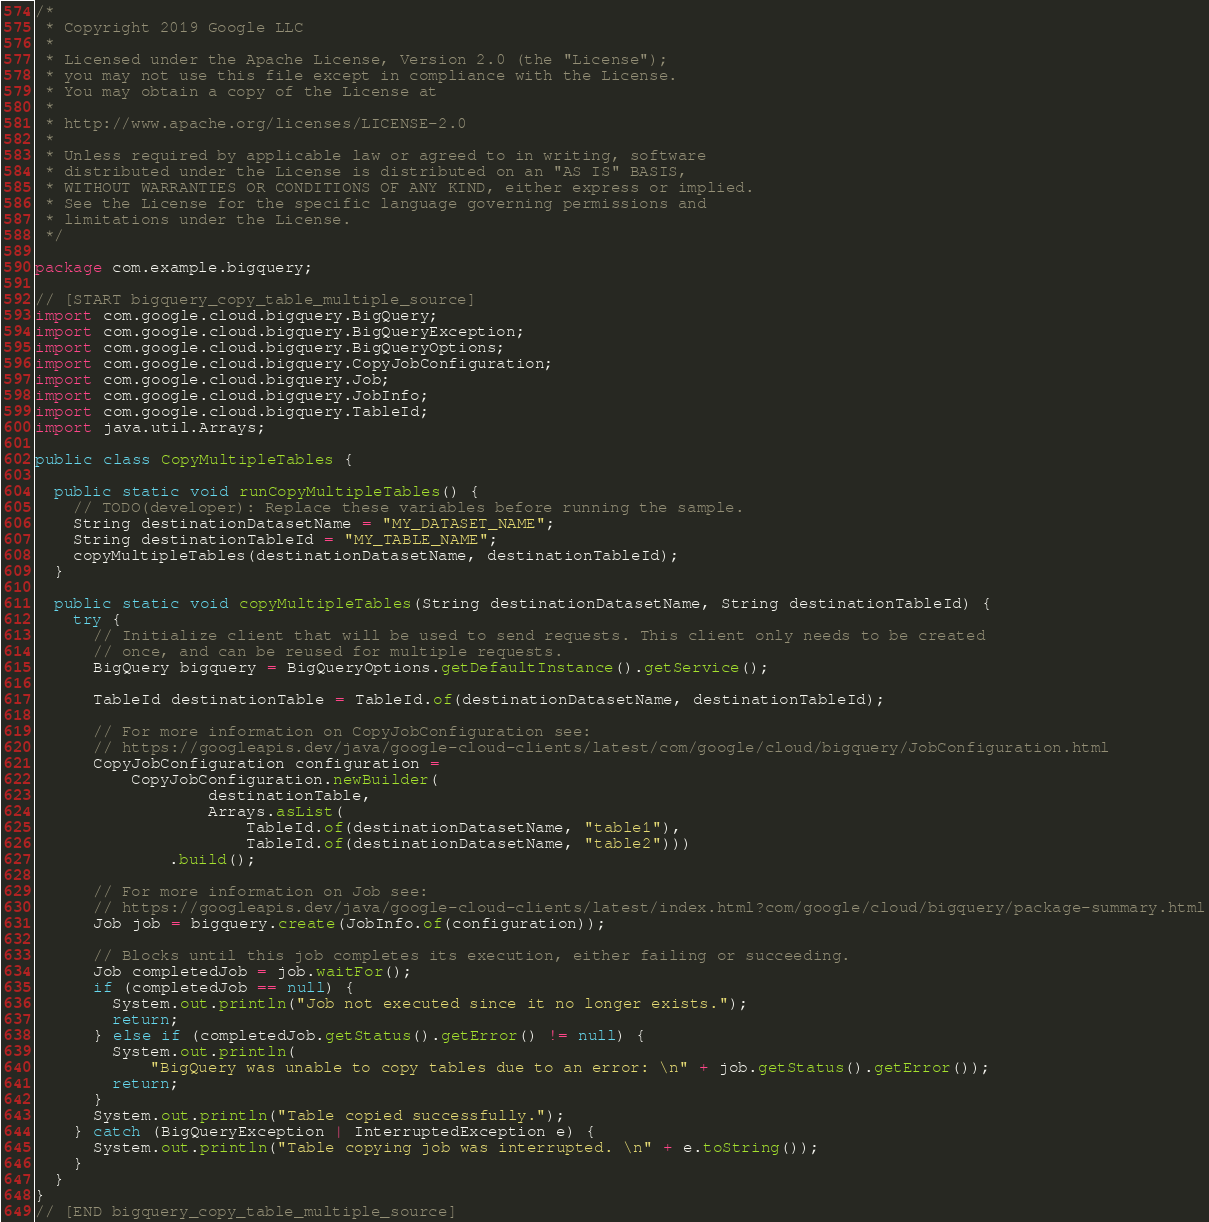<code> <loc_0><loc_0><loc_500><loc_500><_Java_>/*
 * Copyright 2019 Google LLC
 *
 * Licensed under the Apache License, Version 2.0 (the "License");
 * you may not use this file except in compliance with the License.
 * You may obtain a copy of the License at
 *
 * http://www.apache.org/licenses/LICENSE-2.0
 *
 * Unless required by applicable law or agreed to in writing, software
 * distributed under the License is distributed on an "AS IS" BASIS,
 * WITHOUT WARRANTIES OR CONDITIONS OF ANY KIND, either express or implied.
 * See the License for the specific language governing permissions and
 * limitations under the License.
 */

package com.example.bigquery;

// [START bigquery_copy_table_multiple_source]
import com.google.cloud.bigquery.BigQuery;
import com.google.cloud.bigquery.BigQueryException;
import com.google.cloud.bigquery.BigQueryOptions;
import com.google.cloud.bigquery.CopyJobConfiguration;
import com.google.cloud.bigquery.Job;
import com.google.cloud.bigquery.JobInfo;
import com.google.cloud.bigquery.TableId;
import java.util.Arrays;

public class CopyMultipleTables {

  public static void runCopyMultipleTables() {
    // TODO(developer): Replace these variables before running the sample.
    String destinationDatasetName = "MY_DATASET_NAME";
    String destinationTableId = "MY_TABLE_NAME";
    copyMultipleTables(destinationDatasetName, destinationTableId);
  }

  public static void copyMultipleTables(String destinationDatasetName, String destinationTableId) {
    try {
      // Initialize client that will be used to send requests. This client only needs to be created
      // once, and can be reused for multiple requests.
      BigQuery bigquery = BigQueryOptions.getDefaultInstance().getService();

      TableId destinationTable = TableId.of(destinationDatasetName, destinationTableId);

      // For more information on CopyJobConfiguration see:
      // https://googleapis.dev/java/google-cloud-clients/latest/com/google/cloud/bigquery/JobConfiguration.html
      CopyJobConfiguration configuration =
          CopyJobConfiguration.newBuilder(
                  destinationTable,
                  Arrays.asList(
                      TableId.of(destinationDatasetName, "table1"),
                      TableId.of(destinationDatasetName, "table2")))
              .build();

      // For more information on Job see:
      // https://googleapis.dev/java/google-cloud-clients/latest/index.html?com/google/cloud/bigquery/package-summary.html
      Job job = bigquery.create(JobInfo.of(configuration));

      // Blocks until this job completes its execution, either failing or succeeding.
      Job completedJob = job.waitFor();
      if (completedJob == null) {
        System.out.println("Job not executed since it no longer exists.");
        return;
      } else if (completedJob.getStatus().getError() != null) {
        System.out.println(
            "BigQuery was unable to copy tables due to an error: \n" + job.getStatus().getError());
        return;
      }
      System.out.println("Table copied successfully.");
    } catch (BigQueryException | InterruptedException e) {
      System.out.println("Table copying job was interrupted. \n" + e.toString());
    }
  }
}
// [END bigquery_copy_table_multiple_source]
</code> 